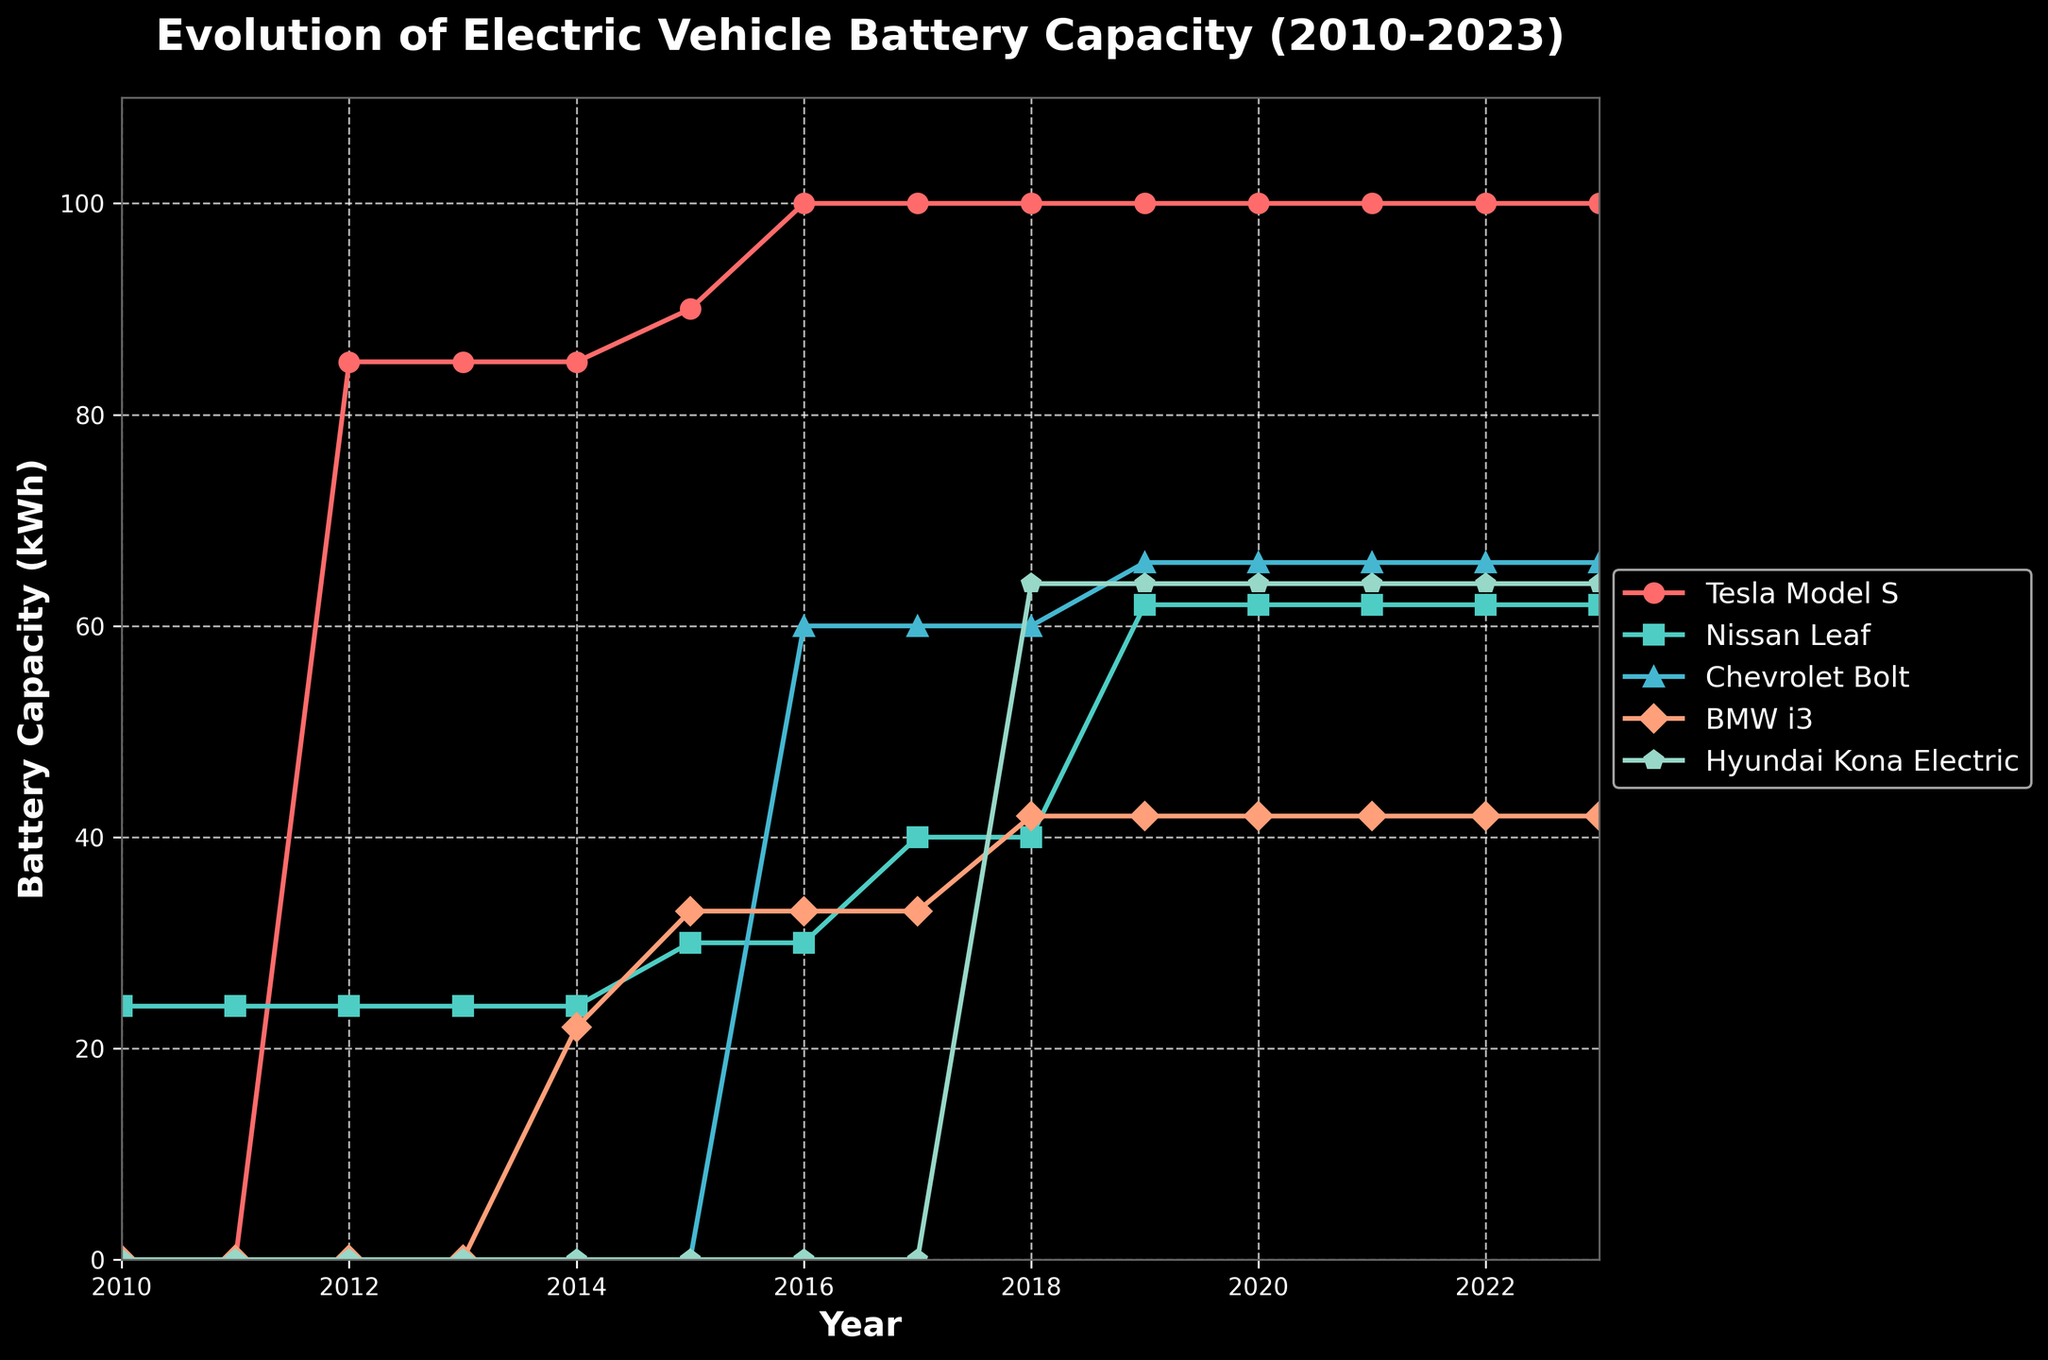What's the range of battery capacities for the Tesla Model S from 2012 to 2023? From 2012 to 2023, the Tesla Model S is the red line showing the battery capacities ranging from 85 kWh to 100 kWh. Therefore, the range of battery capacities for the Tesla Model S is from 85 kWh to 100 kWh.
Answer: 85 kWh to 100 kWh In what year did the BMW i3 first appear in the data set, and what was its initial battery capacity? The BMW i3 is represented by the yellow line. It first appears in the data set in 2014, and its initial battery capacity was 22 kWh.
Answer: 2014, 22 kWh How many years did it take for the Nissan Leaf's battery capacity to increase from 24 kWh to 62 kWh? The light green line represents the Nissan Leaf. Its battery capacity was 24 kWh from 2010 to 2016 and increased to 62 kWh by 2019. So, it took (2019 - 2017) = 2 years after the change started to complete the increase to 62 kWh.
Answer: 2 years Which electric vehicle had the highest battery capacity in 2016, and what was its capacity? By looking at the lines and data points for 2016, the Tesla Model S had the highest battery capacity at that time, which was 100 kWh.
Answer: Tesla Model S, 100 kWh Compare the battery capacities of the Hyundai Kona Electric and Chevrolet Bolt in 2019. Which one had a higher capacity, and by how much? In the year 2019, the Hyundai Kona Electric (light blue line) had a battery capacity of 64 kWh, while the Chevrolet Bolt (green line) had a capacity of 66 kWh. The Chevrolet Bolt had a higher capacity by (66 - 64) = 2 kWh.
Answer: Chevrolet Bolt, 2 kWh What is the average battery capacity of the Nissan Leaf during the period 2010-2023? The battery capacities of the Nissan Leaf from 2010 to 2023 are: 24, 24, 24, 24, 24, 30, 30, 40, 40, 62, 62, 62, 62, and 62 kWh. Summing these up gives a total of 520 kWh. Dividing by the number of years (14) gives an average of 520/14 ≈ 37.14 kWh.
Answer: 37.14 kWh Which vehicle showed no change in battery capacity from 2018 to 2023, and what was the capacity? By observing the flat lines from 2018 to 2023, both the Tesla Model S (red line) and Chevrolet Bolt (green line) showed no change in battery capacities. The capacities were 100 kWh for the Tesla Model S and 66 kWh for the Chevrolet Bolt.
Answer: Tesla Model S, 100 kWh; Chevrolet Bolt, 66 kWh 